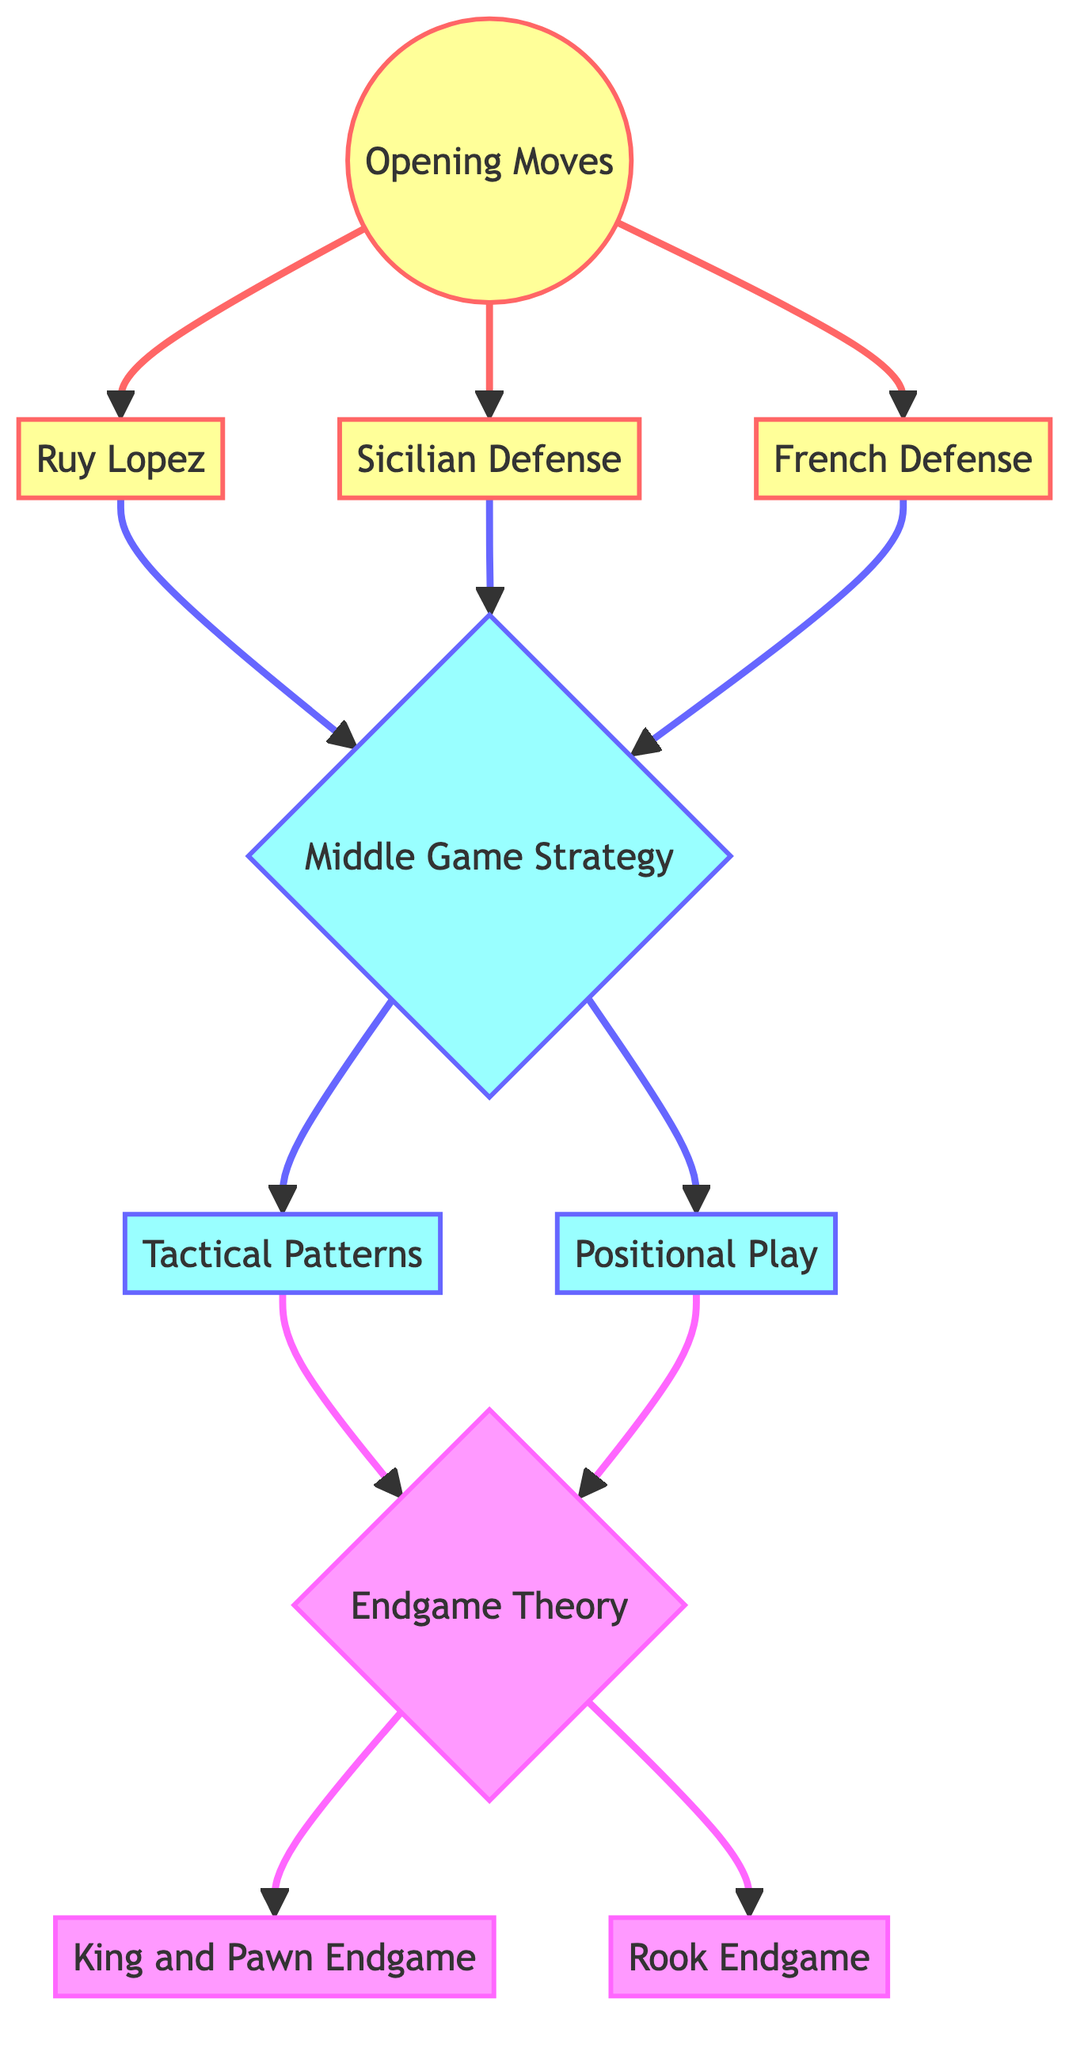What's the total number of nodes in the diagram? By counting the distinct nodes listed in the data, we find a total of 10 nodes: Opening Moves, Ruy Lopez, Sicilian Defense, French Defense, Middle Game Strategy, Tactical Patterns, Positional Play, Endgame Theory, King and Pawn Endgame, and Rook Endgame.
Answer: 10 What is the first opening move listed in the diagram? The first opening move node directly linked from Opening Moves is Ruy Lopez. It is the first one in the data structure, indicating its primary position in the hierarchy.
Answer: Ruy Lopez How many different openings are connected to Opening Moves? There are three distinct openings connected to Opening Moves: Ruy Lopez, Sicilian Defense, and French Defense, as derived from the edges linked from the Opening Moves node.
Answer: 3 Which Middle Game Strategy node leads to Tactical Patterns? The node Middle Game Strategy has a directed edge leading to Tactical Patterns. This is the only node directly connecting from Middle Game Strategy to Tactical Patterns, indicating a straightforward path.
Answer: Middle Game Strategy What are the two endgames connected to Endgame Theory? Endgame Theory has two outgoing edges leading to King and Pawn Endgame and Rook Endgame, indicating these are the specific endgame types that stem from the Endgame Theory node.
Answer: King and Pawn Endgame, Rook Endgame What is the relationship between French Defense and Middle Game Strategy? French Defense has a direct edge leading to Middle Game Strategy, indicating that after playing the French Defense, the next phase of the game being considered is Middle Game Strategy.
Answer: Direct edge Which node links Tactical Patterns to Endgame Theory? The node Tactical Patterns has an outgoing edge that connects directly to Endgame Theory, indicating a progression from tactical awareness to the understanding of endgame principles.
Answer: Endgame Theory What is the total number of edges in the diagram? By counting the edges connecting the nodes, we find a total of 11 edges that indicate the connections and relationships between the nodes throughout the directed graph.
Answer: 11 Which openings lead directly to Middle Game Strategy? The openings that connect directly to Middle Game Strategy are Ruy Lopez, Sicilian Defense, and French Defense, indicating that each opening contributes to the strategy in the middle game.
Answer: Ruy Lopez, Sicilian Defense, French Defense Which node represents Positional Play? Positional Play is represented as a distinct node within the diagram, showing its relevance in the progression from Middle Game Strategy to Endgame Theory.
Answer: Positional Play 